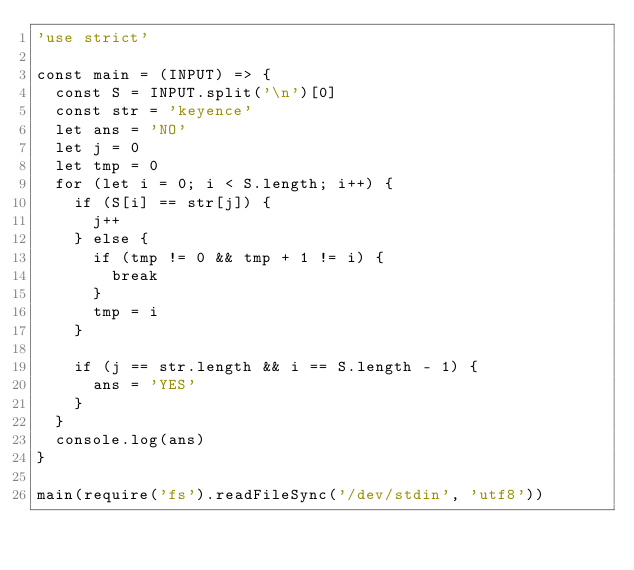<code> <loc_0><loc_0><loc_500><loc_500><_JavaScript_>'use strict'

const main = (INPUT) => {
  const S = INPUT.split('\n')[0]
  const str = 'keyence'
  let ans = 'NO'
  let j = 0
  let tmp = 0
  for (let i = 0; i < S.length; i++) {
    if (S[i] == str[j]) {
      j++
    } else {
      if (tmp != 0 && tmp + 1 != i) {
        break
      }
      tmp = i
    }

    if (j == str.length && i == S.length - 1) {
      ans = 'YES'
    }
  }
  console.log(ans)
}

main(require('fs').readFileSync('/dev/stdin', 'utf8'))
</code> 